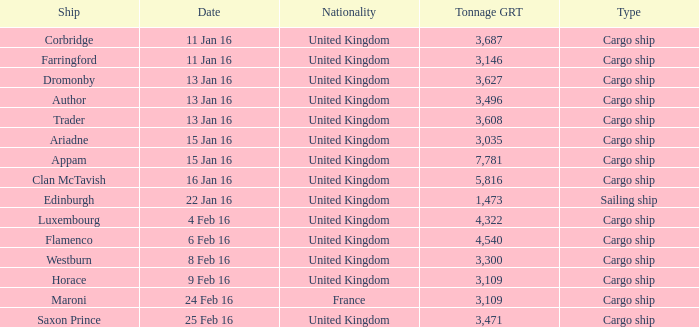What is the total tonnage grt of the cargo ship(s) sunk or captured on 4 feb 16? 1.0. 